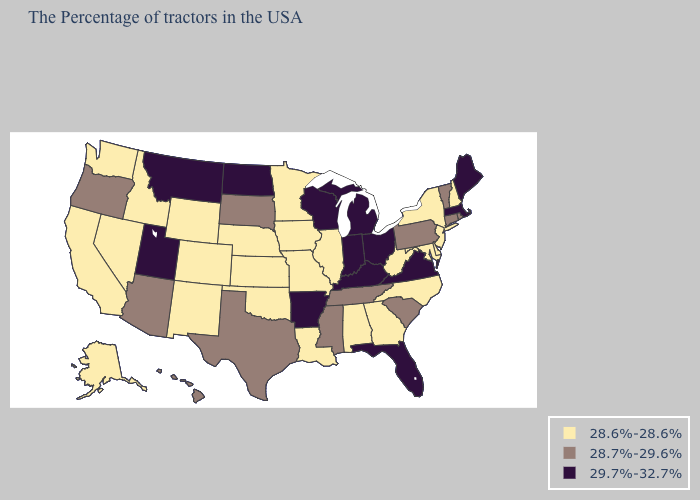Does Kansas have a lower value than Iowa?
Be succinct. No. What is the value of Maine?
Quick response, please. 29.7%-32.7%. Name the states that have a value in the range 28.7%-29.6%?
Keep it brief. Rhode Island, Vermont, Connecticut, Pennsylvania, South Carolina, Tennessee, Mississippi, Texas, South Dakota, Arizona, Oregon, Hawaii. Name the states that have a value in the range 28.6%-28.6%?
Short answer required. New Hampshire, New York, New Jersey, Delaware, Maryland, North Carolina, West Virginia, Georgia, Alabama, Illinois, Louisiana, Missouri, Minnesota, Iowa, Kansas, Nebraska, Oklahoma, Wyoming, Colorado, New Mexico, Idaho, Nevada, California, Washington, Alaska. Does Missouri have the lowest value in the USA?
Short answer required. Yes. Does Washington have the highest value in the USA?
Keep it brief. No. What is the value of Alabama?
Answer briefly. 28.6%-28.6%. Name the states that have a value in the range 28.6%-28.6%?
Keep it brief. New Hampshire, New York, New Jersey, Delaware, Maryland, North Carolina, West Virginia, Georgia, Alabama, Illinois, Louisiana, Missouri, Minnesota, Iowa, Kansas, Nebraska, Oklahoma, Wyoming, Colorado, New Mexico, Idaho, Nevada, California, Washington, Alaska. Does Wyoming have the lowest value in the West?
Answer briefly. Yes. Name the states that have a value in the range 29.7%-32.7%?
Short answer required. Maine, Massachusetts, Virginia, Ohio, Florida, Michigan, Kentucky, Indiana, Wisconsin, Arkansas, North Dakota, Utah, Montana. Which states have the highest value in the USA?
Give a very brief answer. Maine, Massachusetts, Virginia, Ohio, Florida, Michigan, Kentucky, Indiana, Wisconsin, Arkansas, North Dakota, Utah, Montana. What is the lowest value in the USA?
Keep it brief. 28.6%-28.6%. Name the states that have a value in the range 28.6%-28.6%?
Be succinct. New Hampshire, New York, New Jersey, Delaware, Maryland, North Carolina, West Virginia, Georgia, Alabama, Illinois, Louisiana, Missouri, Minnesota, Iowa, Kansas, Nebraska, Oklahoma, Wyoming, Colorado, New Mexico, Idaho, Nevada, California, Washington, Alaska. What is the value of Connecticut?
Quick response, please. 28.7%-29.6%. 